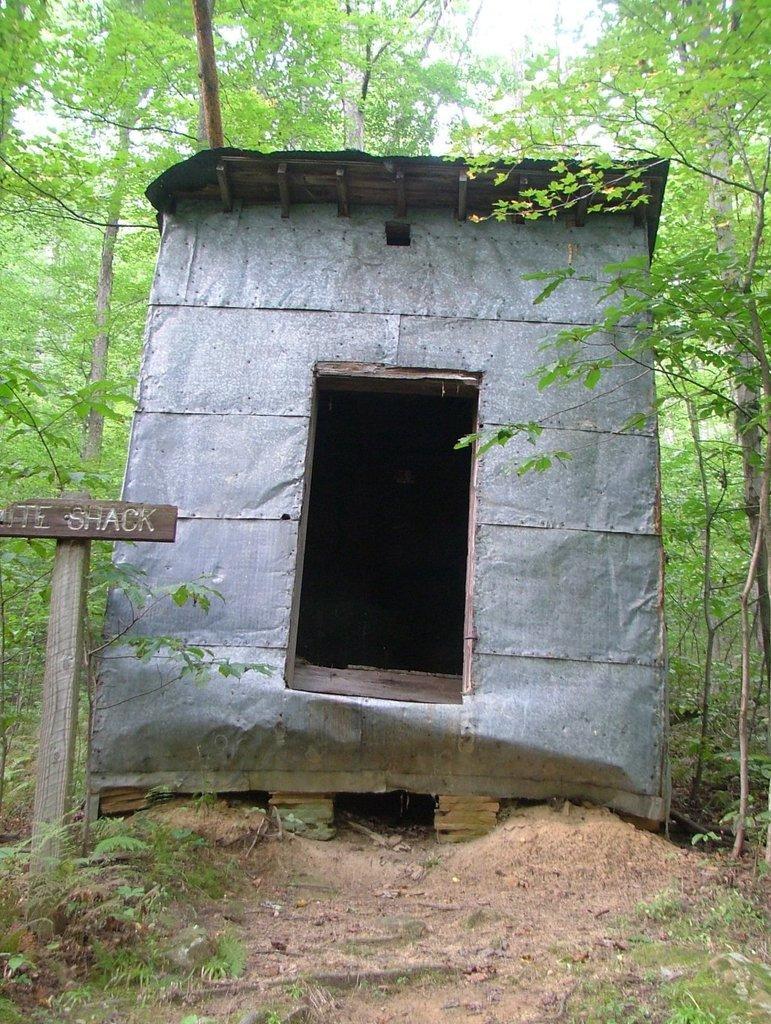Can you describe this image briefly? In this image I can see a shark, a board, grass, number of trees and on this board I can see something is written. 